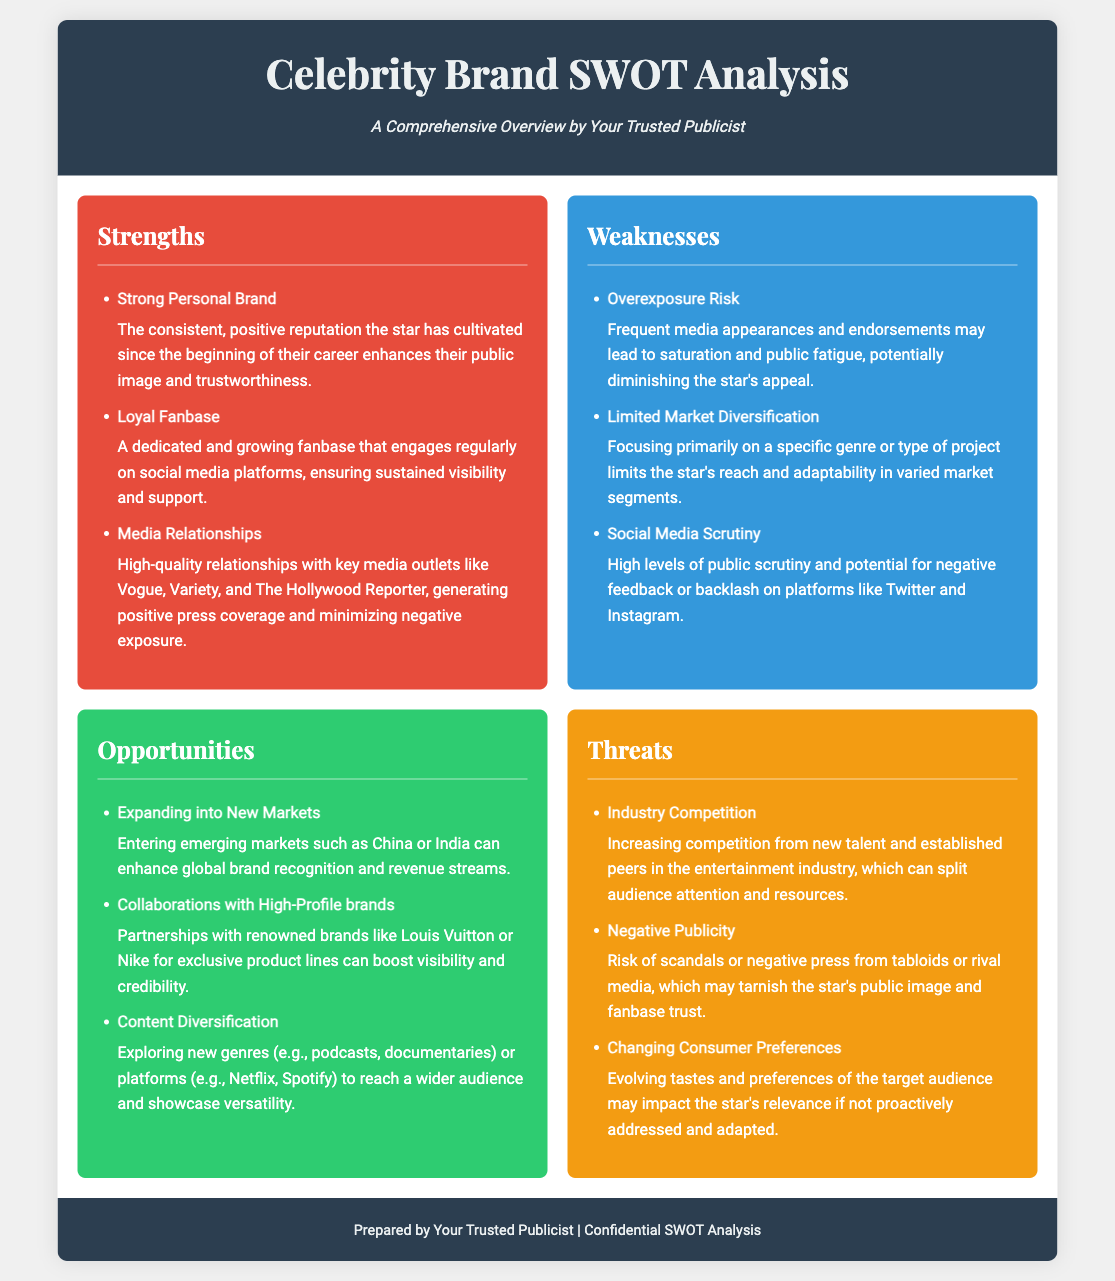What are the strengths listed in the document? The strengths are specific attributes that enhance the star's brand, such as "Strong Personal Brand," "Loyal Fanbase," and "Media Relationships."
Answer: Strong Personal Brand, Loyal Fanbase, Media Relationships What is a key weakness mentioned? A key weakness outlines aspects that could detract from the star's appeal, like "Overexposure Risk."
Answer: Overexposure Risk Which opportunity involves new markets? This opportunity discusses the star's potential to enter emerging markets, specifically mentioning "China or India."
Answer: Expanding into New Markets What is one of the threats related to the industry? The threats included aspects that could pose risks to the star's brand, one of which is "Industry Competition."
Answer: Industry Competition How many strengths are identified in the SWOT analysis? The number of strengths is counted directly from the document's section on strengths.
Answer: 3 What is the main implication of "Negative Publicity"? This threat implies potential harm to the star’s reputation due to unfavorable media, affecting fan trust.
Answer: Risk of scandals or negative press Which aspect does "Collaborations with High-Profile brands" suggest? This aspect suggests partnerships that can enhance visibility and credibility in the market.
Answer: Boost visibility and credibility What type of consumer trend might affect the star's relevance? The document highlights the "Changing Consumer Preferences" as a trend impacting audience connection.
Answer: Changing Consumer Preferences What is the purpose of the SWOT analysis? The purpose is to provide a comprehensive overview of the factors affecting the star's brand and public image.
Answer: A Comprehensive Overview 